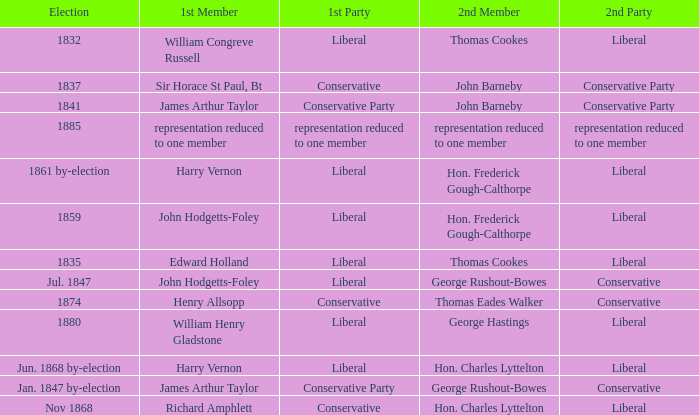What was the 2nd Party, when the 1st Member was John Hodgetts-Foley, and the 2nd Member was Hon. Frederick Gough-Calthorpe? Liberal. 